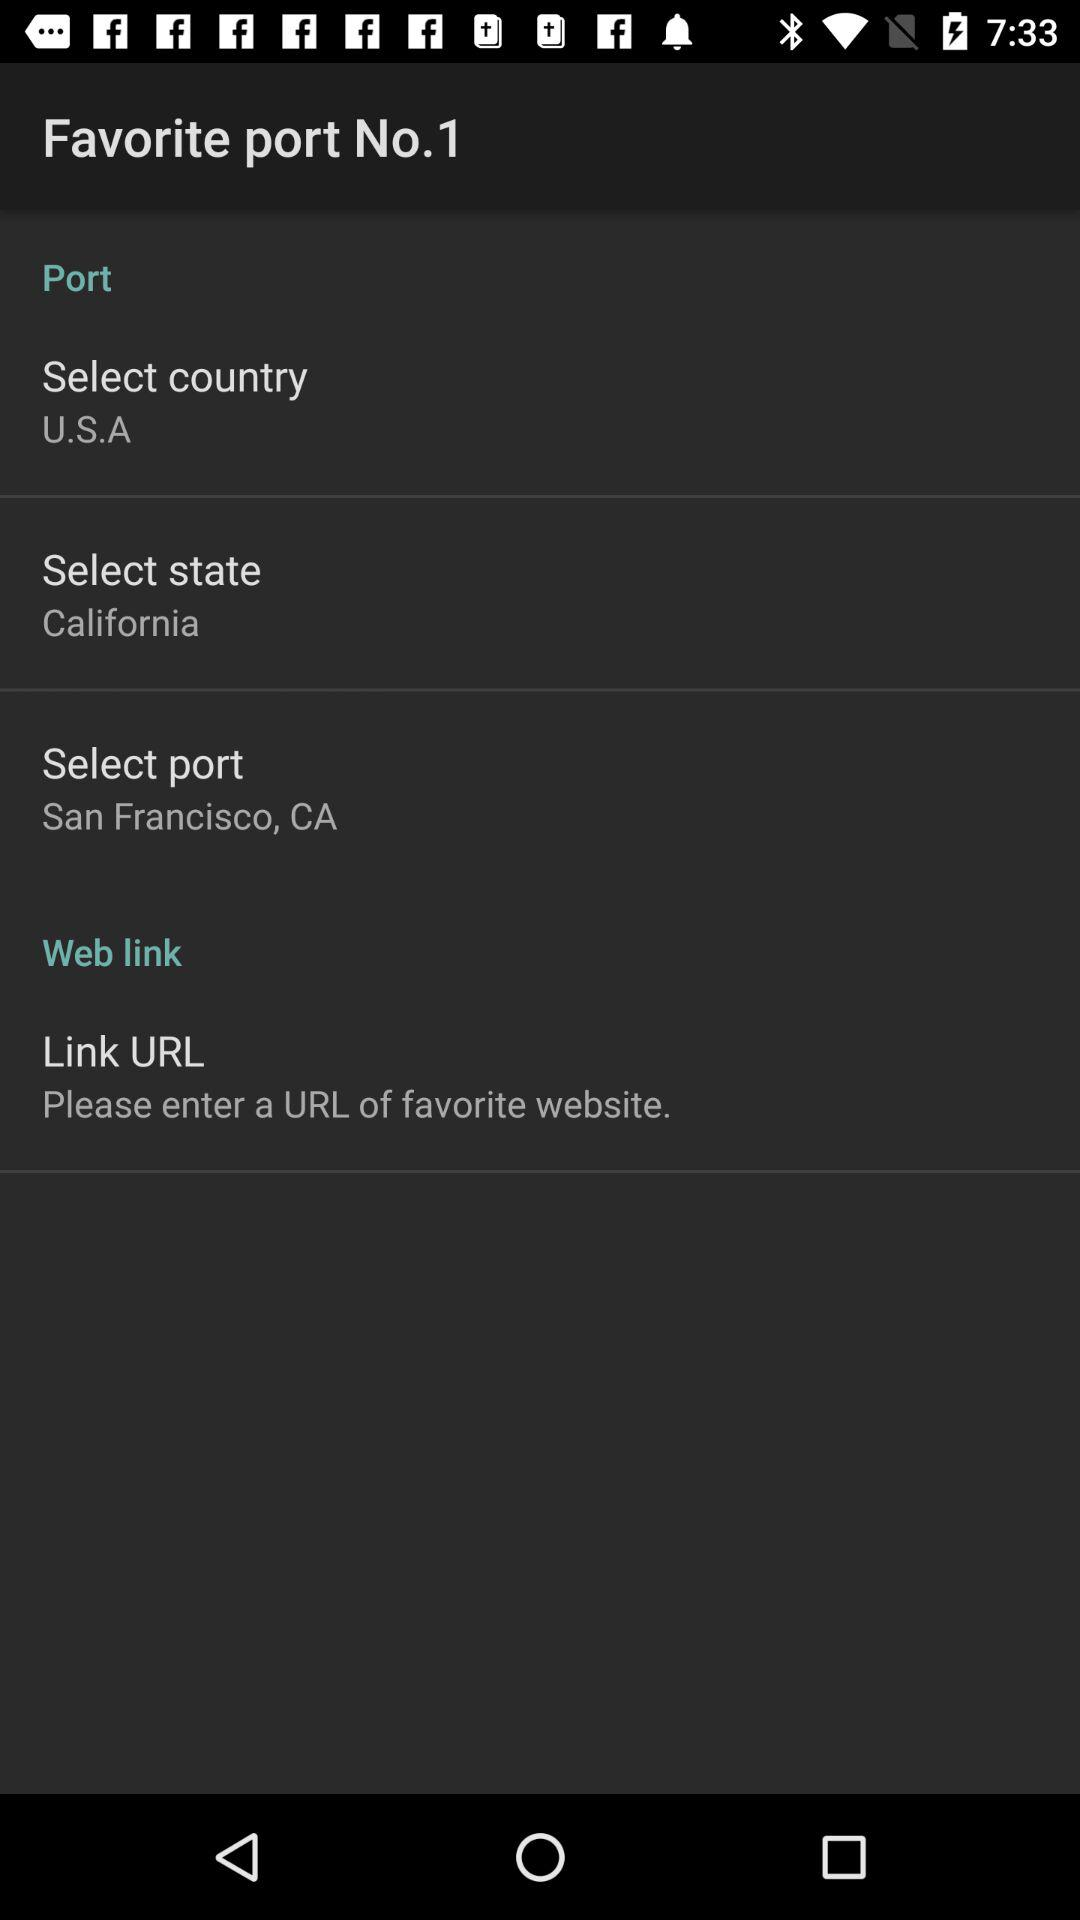What state is selected? The selected state is California. 